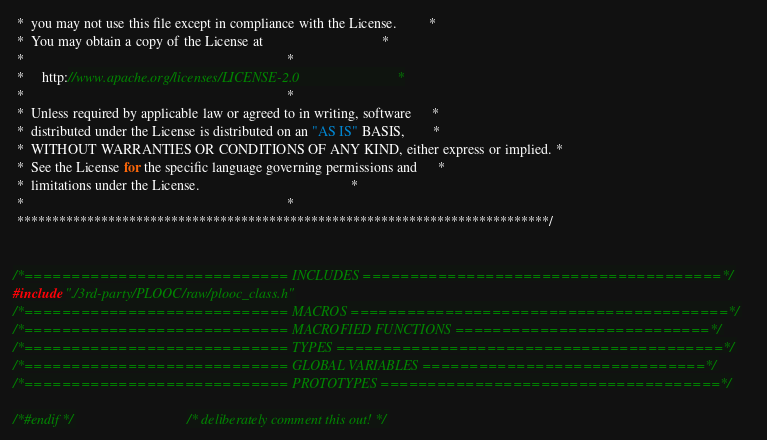<code> <loc_0><loc_0><loc_500><loc_500><_C_> *  you may not use this file except in compliance with the License.         *
 *  You may obtain a copy of the License at                                  *
 *                                                                           *
 *     http://www.apache.org/licenses/LICENSE-2.0                            *
 *                                                                           *
 *  Unless required by applicable law or agreed to in writing, software      *
 *  distributed under the License is distributed on an "AS IS" BASIS,        *
 *  WITHOUT WARRANTIES OR CONDITIONS OF ANY KIND, either express or implied. *
 *  See the License for the specific language governing permissions and      *
 *  limitations under the License.                                           *
 *                                                                           *
 ****************************************************************************/


/*============================ INCLUDES ======================================*/
#include "./3rd-party/PLOOC/raw/plooc_class.h"
/*============================ MACROS ========================================*/
/*============================ MACROFIED FUNCTIONS ===========================*/
/*============================ TYPES =========================================*/
/*============================ GLOBAL VARIABLES ==============================*/
/*============================ PROTOTYPES ====================================*/

/*#endif */                                /* deliberately comment this out! */
</code> 